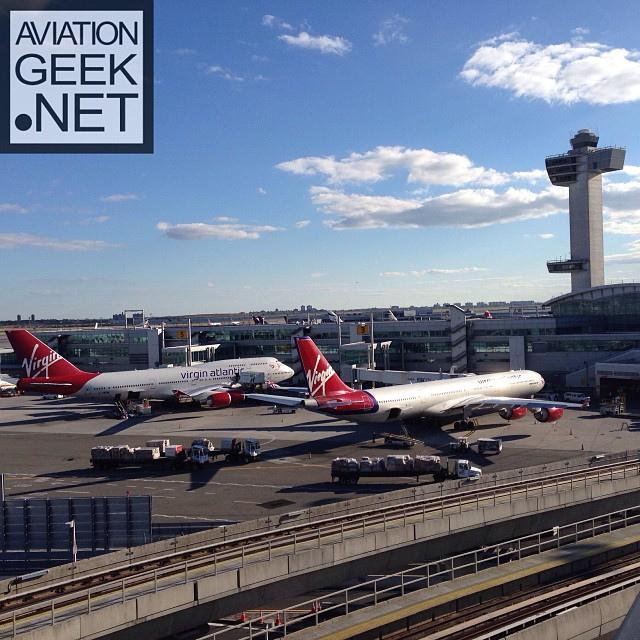What state has a name closest to the name that is found on the vehicle? virginia 